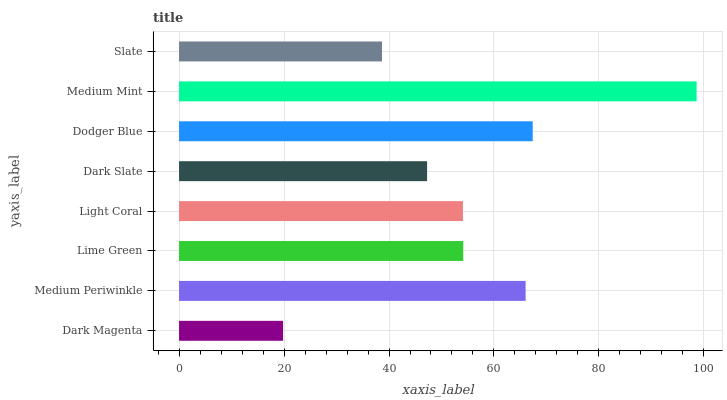Is Dark Magenta the minimum?
Answer yes or no. Yes. Is Medium Mint the maximum?
Answer yes or no. Yes. Is Medium Periwinkle the minimum?
Answer yes or no. No. Is Medium Periwinkle the maximum?
Answer yes or no. No. Is Medium Periwinkle greater than Dark Magenta?
Answer yes or no. Yes. Is Dark Magenta less than Medium Periwinkle?
Answer yes or no. Yes. Is Dark Magenta greater than Medium Periwinkle?
Answer yes or no. No. Is Medium Periwinkle less than Dark Magenta?
Answer yes or no. No. Is Lime Green the high median?
Answer yes or no. Yes. Is Light Coral the low median?
Answer yes or no. Yes. Is Slate the high median?
Answer yes or no. No. Is Dark Slate the low median?
Answer yes or no. No. 